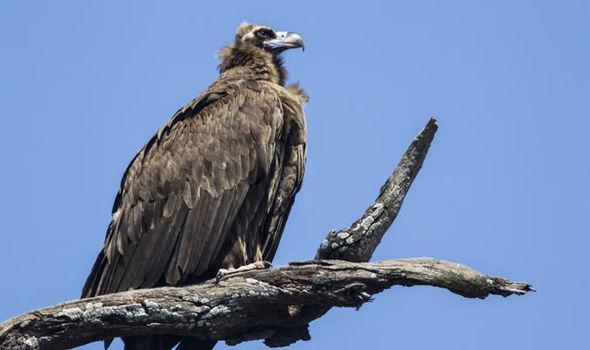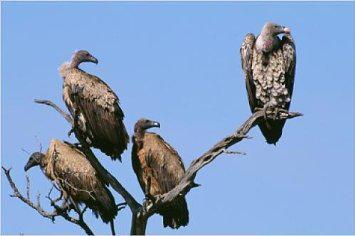The first image is the image on the left, the second image is the image on the right. Considering the images on both sides, is "There are three vultures" valid? Answer yes or no. No. 